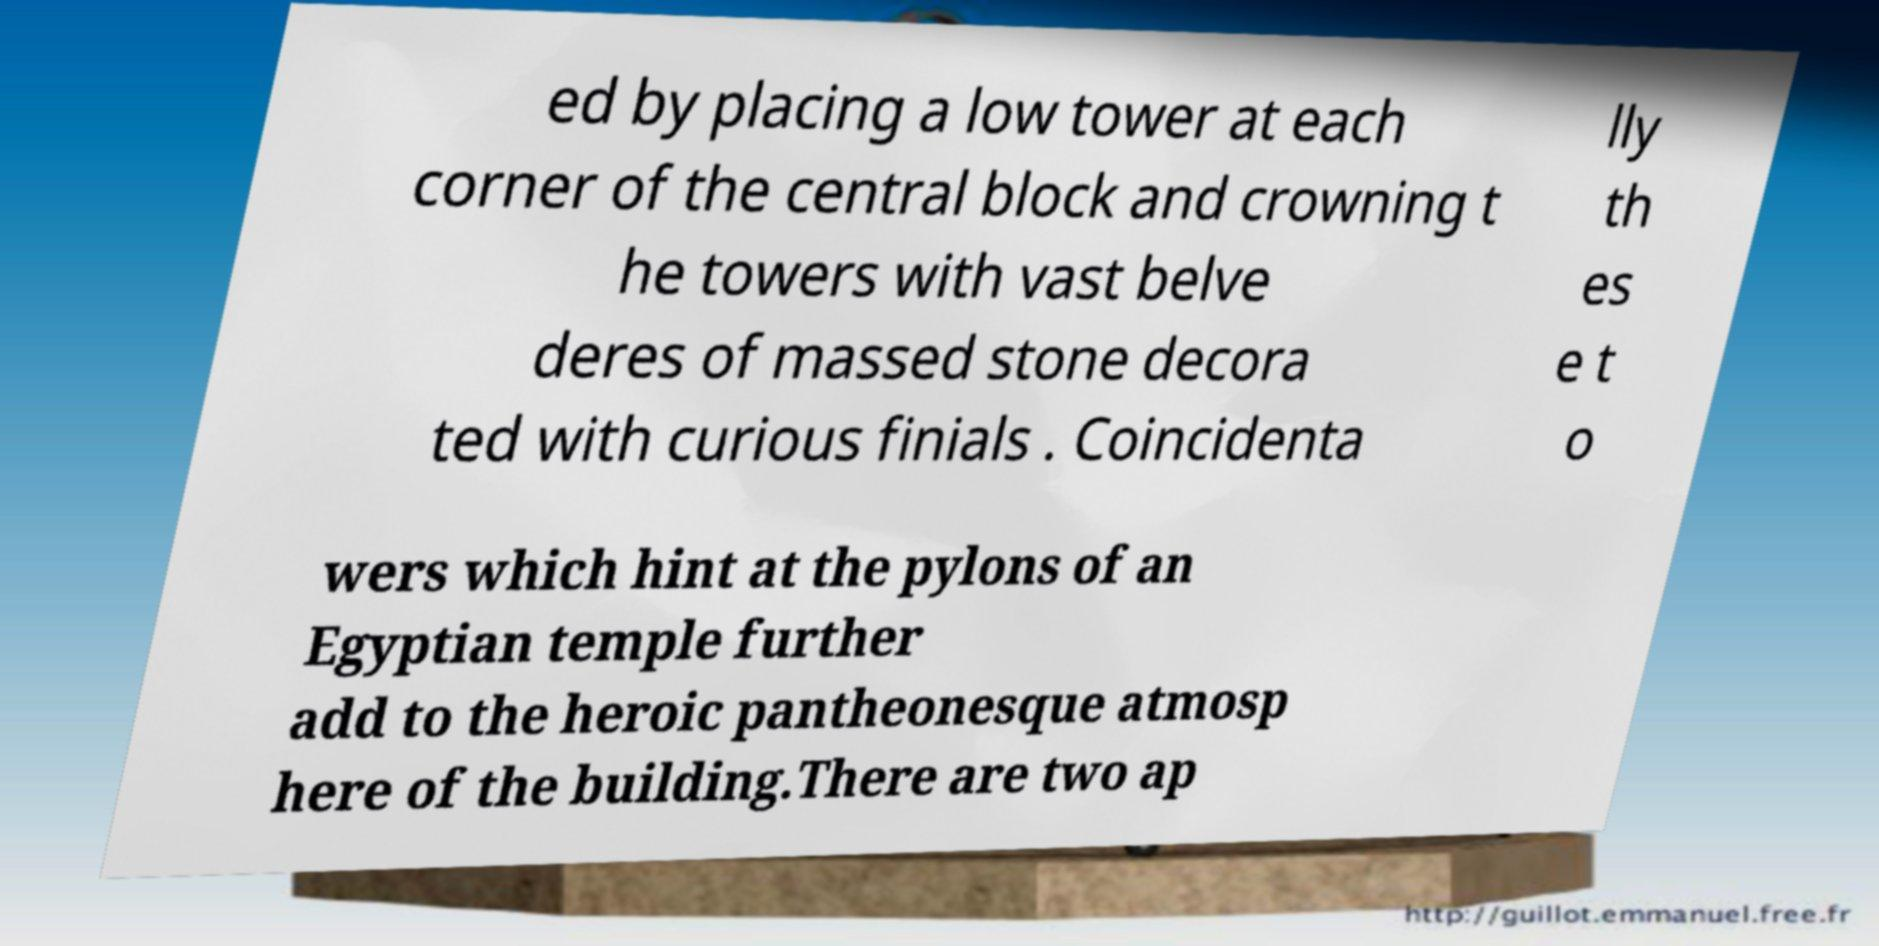Please read and relay the text visible in this image. What does it say? ed by placing a low tower at each corner of the central block and crowning t he towers with vast belve deres of massed stone decora ted with curious finials . Coincidenta lly th es e t o wers which hint at the pylons of an Egyptian temple further add to the heroic pantheonesque atmosp here of the building.There are two ap 